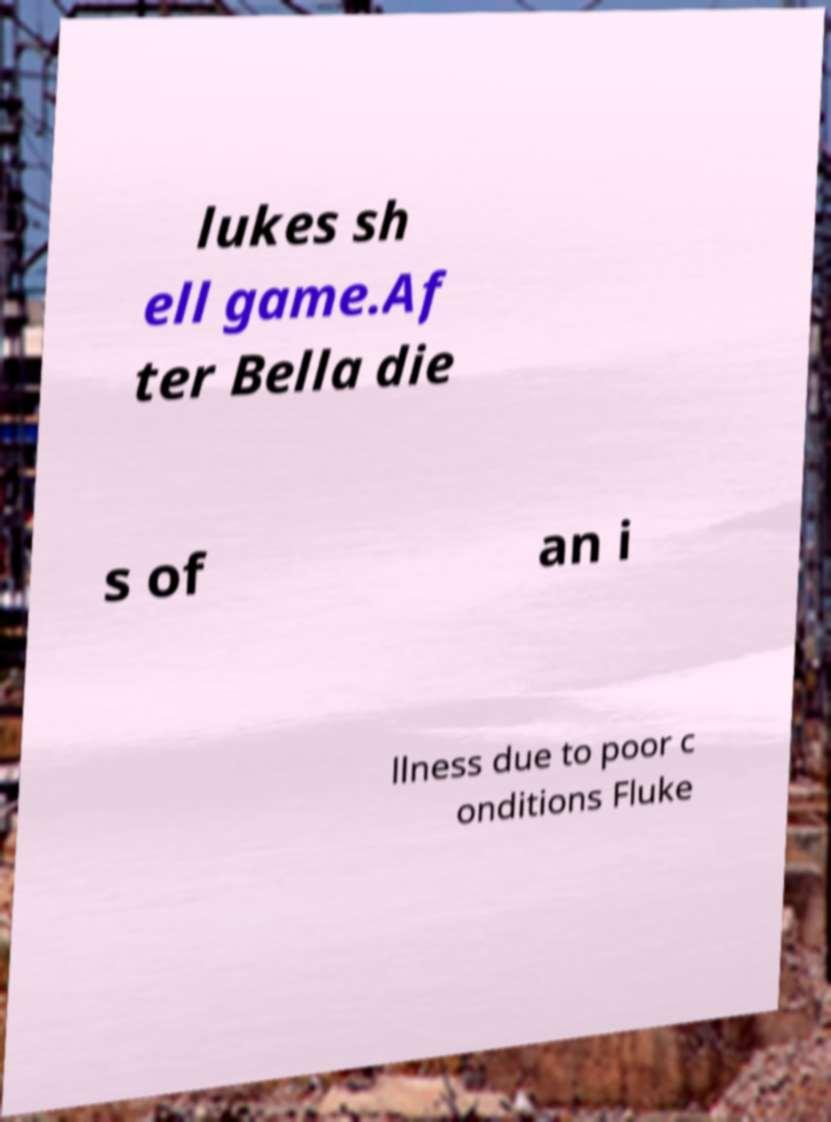Could you extract and type out the text from this image? lukes sh ell game.Af ter Bella die s of an i llness due to poor c onditions Fluke 